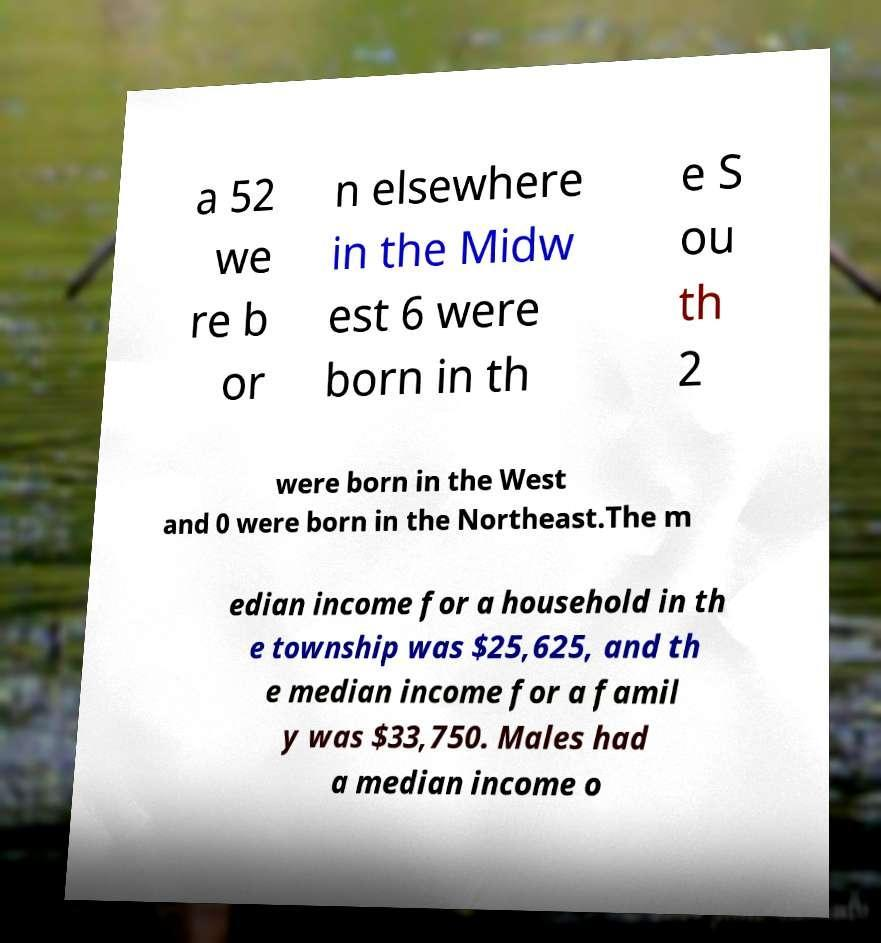Can you read and provide the text displayed in the image?This photo seems to have some interesting text. Can you extract and type it out for me? a 52 we re b or n elsewhere in the Midw est 6 were born in th e S ou th 2 were born in the West and 0 were born in the Northeast.The m edian income for a household in th e township was $25,625, and th e median income for a famil y was $33,750. Males had a median income o 